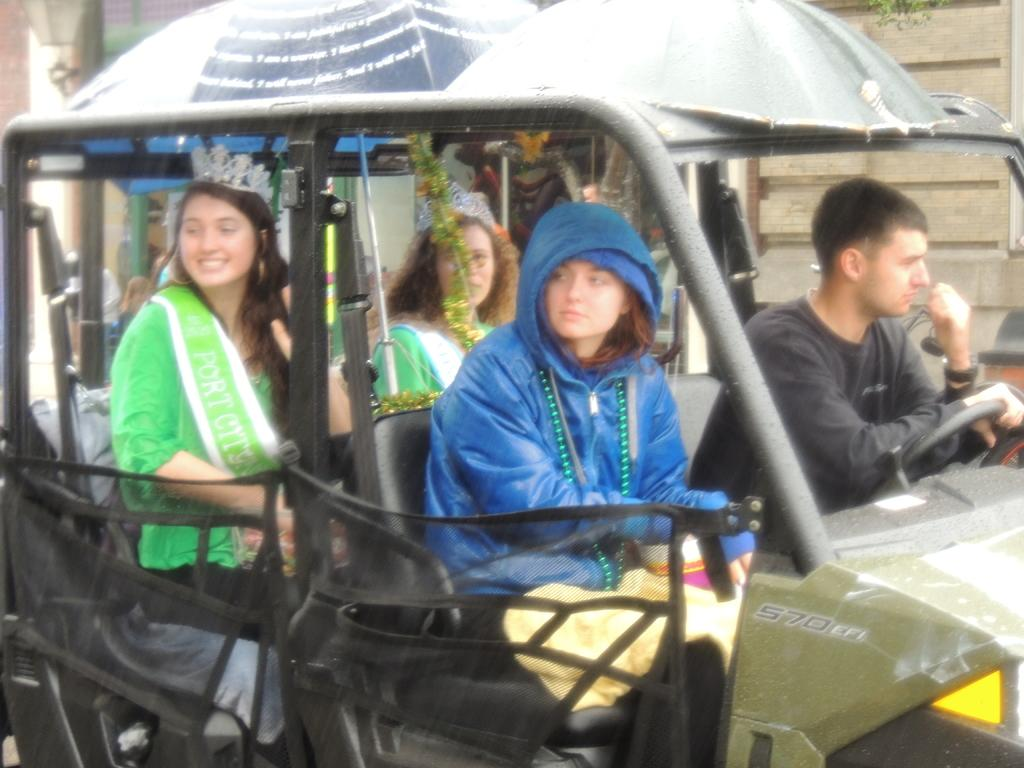How many people are in the image? There are people in the image. What are the people wearing? The people are wearing clothes. Can you identify any specific individuals in the image? Two people are wearing crowns. What are the two people wearing crowns doing? The two people wearing crowns are sitting on a vehicle. What can be seen in the background of the image? There are leaves visible in the image. What type of object can be seen in the image that provides light? There is a lamp in the image. What type of book is the person holding in the image? There is no person holding a book in the image. What type of beef is being prepared in the image? There is no beef present in the image. 